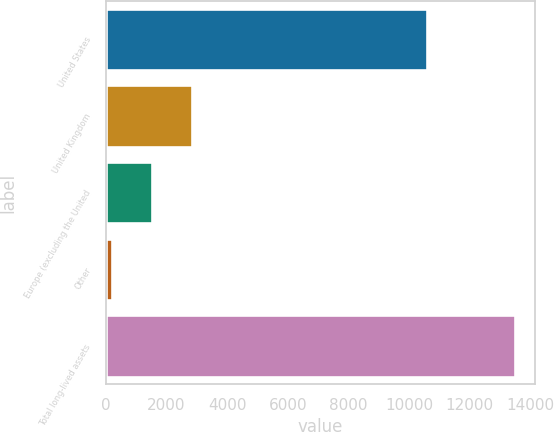<chart> <loc_0><loc_0><loc_500><loc_500><bar_chart><fcel>United States<fcel>United Kingdom<fcel>Europe (excluding the United<fcel>Other<fcel>Total long-lived assets<nl><fcel>10598<fcel>2853.2<fcel>1525.1<fcel>197<fcel>13478<nl></chart> 